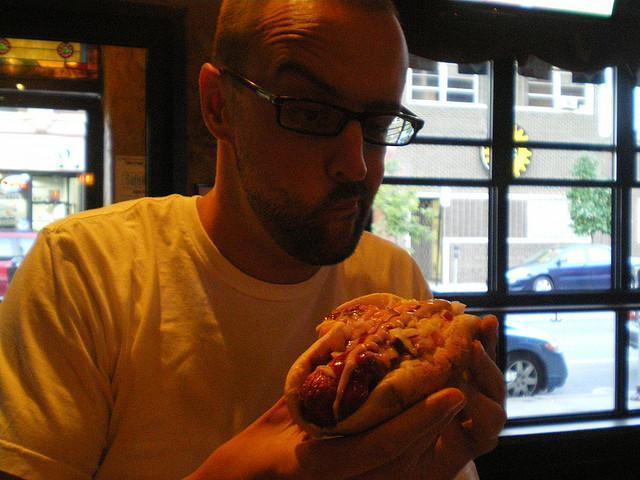How many cars are in the photo?
Give a very brief answer. 2. 